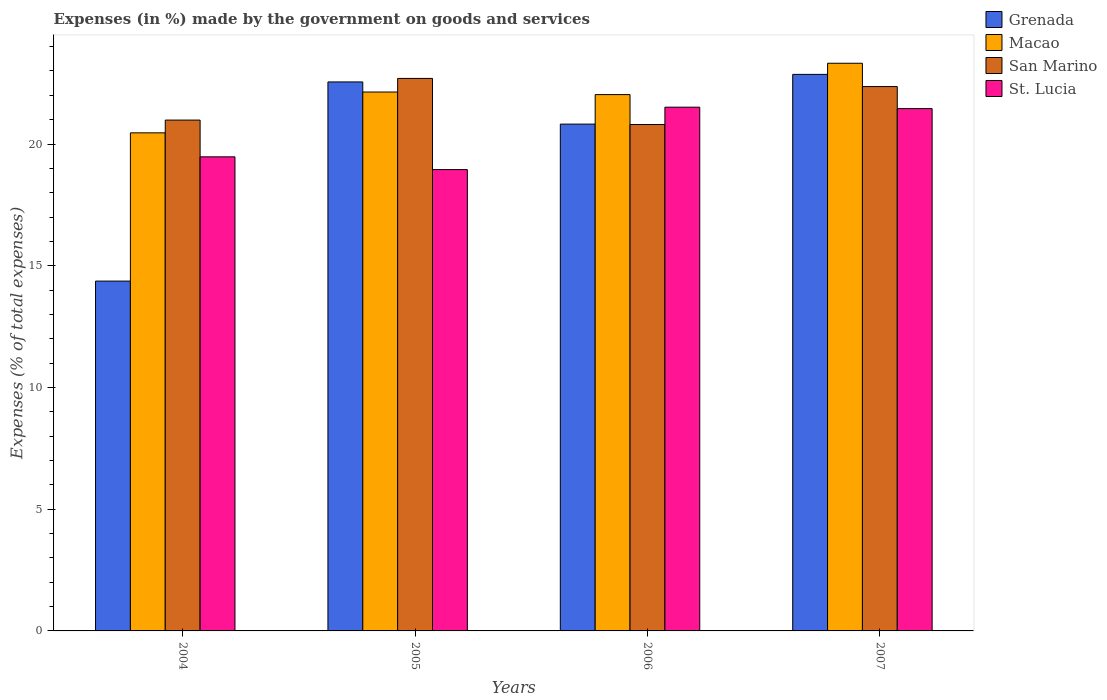How many different coloured bars are there?
Offer a very short reply. 4. Are the number of bars on each tick of the X-axis equal?
Give a very brief answer. Yes. How many bars are there on the 2nd tick from the left?
Provide a short and direct response. 4. What is the label of the 2nd group of bars from the left?
Make the answer very short. 2005. In how many cases, is the number of bars for a given year not equal to the number of legend labels?
Provide a succinct answer. 0. What is the percentage of expenses made by the government on goods and services in Grenada in 2004?
Your answer should be very brief. 14.37. Across all years, what is the maximum percentage of expenses made by the government on goods and services in Grenada?
Keep it short and to the point. 22.86. Across all years, what is the minimum percentage of expenses made by the government on goods and services in Grenada?
Provide a succinct answer. 14.37. In which year was the percentage of expenses made by the government on goods and services in Grenada maximum?
Provide a short and direct response. 2007. In which year was the percentage of expenses made by the government on goods and services in Macao minimum?
Ensure brevity in your answer.  2004. What is the total percentage of expenses made by the government on goods and services in St. Lucia in the graph?
Offer a terse response. 81.39. What is the difference between the percentage of expenses made by the government on goods and services in St. Lucia in 2005 and that in 2006?
Provide a succinct answer. -2.56. What is the difference between the percentage of expenses made by the government on goods and services in San Marino in 2005 and the percentage of expenses made by the government on goods and services in Grenada in 2006?
Your answer should be compact. 1.88. What is the average percentage of expenses made by the government on goods and services in St. Lucia per year?
Offer a very short reply. 20.35. In the year 2004, what is the difference between the percentage of expenses made by the government on goods and services in Grenada and percentage of expenses made by the government on goods and services in St. Lucia?
Offer a very short reply. -5.1. In how many years, is the percentage of expenses made by the government on goods and services in St. Lucia greater than 21 %?
Your answer should be compact. 2. What is the ratio of the percentage of expenses made by the government on goods and services in San Marino in 2006 to that in 2007?
Offer a very short reply. 0.93. Is the percentage of expenses made by the government on goods and services in St. Lucia in 2004 less than that in 2005?
Keep it short and to the point. No. What is the difference between the highest and the second highest percentage of expenses made by the government on goods and services in Grenada?
Your response must be concise. 0.31. What is the difference between the highest and the lowest percentage of expenses made by the government on goods and services in St. Lucia?
Offer a very short reply. 2.56. In how many years, is the percentage of expenses made by the government on goods and services in Grenada greater than the average percentage of expenses made by the government on goods and services in Grenada taken over all years?
Give a very brief answer. 3. Is the sum of the percentage of expenses made by the government on goods and services in San Marino in 2004 and 2007 greater than the maximum percentage of expenses made by the government on goods and services in Macao across all years?
Give a very brief answer. Yes. Is it the case that in every year, the sum of the percentage of expenses made by the government on goods and services in Macao and percentage of expenses made by the government on goods and services in Grenada is greater than the sum of percentage of expenses made by the government on goods and services in San Marino and percentage of expenses made by the government on goods and services in St. Lucia?
Make the answer very short. No. What does the 1st bar from the left in 2004 represents?
Your response must be concise. Grenada. What does the 1st bar from the right in 2006 represents?
Offer a terse response. St. Lucia. Is it the case that in every year, the sum of the percentage of expenses made by the government on goods and services in Grenada and percentage of expenses made by the government on goods and services in Macao is greater than the percentage of expenses made by the government on goods and services in St. Lucia?
Ensure brevity in your answer.  Yes. How many bars are there?
Provide a succinct answer. 16. Are all the bars in the graph horizontal?
Provide a succinct answer. No. How many years are there in the graph?
Keep it short and to the point. 4. Are the values on the major ticks of Y-axis written in scientific E-notation?
Give a very brief answer. No. Does the graph contain any zero values?
Give a very brief answer. No. How many legend labels are there?
Keep it short and to the point. 4. How are the legend labels stacked?
Keep it short and to the point. Vertical. What is the title of the graph?
Keep it short and to the point. Expenses (in %) made by the government on goods and services. What is the label or title of the Y-axis?
Provide a succinct answer. Expenses (% of total expenses). What is the Expenses (% of total expenses) in Grenada in 2004?
Make the answer very short. 14.37. What is the Expenses (% of total expenses) in Macao in 2004?
Your answer should be very brief. 20.46. What is the Expenses (% of total expenses) of San Marino in 2004?
Offer a terse response. 20.98. What is the Expenses (% of total expenses) of St. Lucia in 2004?
Offer a terse response. 19.47. What is the Expenses (% of total expenses) in Grenada in 2005?
Ensure brevity in your answer.  22.55. What is the Expenses (% of total expenses) of Macao in 2005?
Make the answer very short. 22.14. What is the Expenses (% of total expenses) in San Marino in 2005?
Your response must be concise. 22.7. What is the Expenses (% of total expenses) in St. Lucia in 2005?
Keep it short and to the point. 18.95. What is the Expenses (% of total expenses) in Grenada in 2006?
Make the answer very short. 20.82. What is the Expenses (% of total expenses) of Macao in 2006?
Offer a very short reply. 22.03. What is the Expenses (% of total expenses) in San Marino in 2006?
Your response must be concise. 20.8. What is the Expenses (% of total expenses) of St. Lucia in 2006?
Ensure brevity in your answer.  21.51. What is the Expenses (% of total expenses) of Grenada in 2007?
Provide a short and direct response. 22.86. What is the Expenses (% of total expenses) of Macao in 2007?
Your answer should be compact. 23.32. What is the Expenses (% of total expenses) in San Marino in 2007?
Offer a very short reply. 22.36. What is the Expenses (% of total expenses) of St. Lucia in 2007?
Give a very brief answer. 21.46. Across all years, what is the maximum Expenses (% of total expenses) in Grenada?
Offer a very short reply. 22.86. Across all years, what is the maximum Expenses (% of total expenses) of Macao?
Ensure brevity in your answer.  23.32. Across all years, what is the maximum Expenses (% of total expenses) in San Marino?
Offer a terse response. 22.7. Across all years, what is the maximum Expenses (% of total expenses) in St. Lucia?
Provide a succinct answer. 21.51. Across all years, what is the minimum Expenses (% of total expenses) in Grenada?
Give a very brief answer. 14.37. Across all years, what is the minimum Expenses (% of total expenses) of Macao?
Provide a short and direct response. 20.46. Across all years, what is the minimum Expenses (% of total expenses) in San Marino?
Give a very brief answer. 20.8. Across all years, what is the minimum Expenses (% of total expenses) of St. Lucia?
Give a very brief answer. 18.95. What is the total Expenses (% of total expenses) of Grenada in the graph?
Ensure brevity in your answer.  80.6. What is the total Expenses (% of total expenses) in Macao in the graph?
Make the answer very short. 87.94. What is the total Expenses (% of total expenses) in San Marino in the graph?
Your answer should be very brief. 86.84. What is the total Expenses (% of total expenses) in St. Lucia in the graph?
Provide a succinct answer. 81.39. What is the difference between the Expenses (% of total expenses) of Grenada in 2004 and that in 2005?
Offer a very short reply. -8.18. What is the difference between the Expenses (% of total expenses) in Macao in 2004 and that in 2005?
Make the answer very short. -1.68. What is the difference between the Expenses (% of total expenses) of San Marino in 2004 and that in 2005?
Offer a very short reply. -1.71. What is the difference between the Expenses (% of total expenses) in St. Lucia in 2004 and that in 2005?
Give a very brief answer. 0.52. What is the difference between the Expenses (% of total expenses) of Grenada in 2004 and that in 2006?
Provide a short and direct response. -6.45. What is the difference between the Expenses (% of total expenses) in Macao in 2004 and that in 2006?
Keep it short and to the point. -1.57. What is the difference between the Expenses (% of total expenses) of San Marino in 2004 and that in 2006?
Your answer should be compact. 0.18. What is the difference between the Expenses (% of total expenses) in St. Lucia in 2004 and that in 2006?
Ensure brevity in your answer.  -2.04. What is the difference between the Expenses (% of total expenses) of Grenada in 2004 and that in 2007?
Keep it short and to the point. -8.49. What is the difference between the Expenses (% of total expenses) in Macao in 2004 and that in 2007?
Give a very brief answer. -2.86. What is the difference between the Expenses (% of total expenses) of San Marino in 2004 and that in 2007?
Give a very brief answer. -1.38. What is the difference between the Expenses (% of total expenses) of St. Lucia in 2004 and that in 2007?
Your answer should be very brief. -1.98. What is the difference between the Expenses (% of total expenses) of Grenada in 2005 and that in 2006?
Make the answer very short. 1.73. What is the difference between the Expenses (% of total expenses) of Macao in 2005 and that in 2006?
Provide a short and direct response. 0.11. What is the difference between the Expenses (% of total expenses) in San Marino in 2005 and that in 2006?
Your answer should be compact. 1.89. What is the difference between the Expenses (% of total expenses) of St. Lucia in 2005 and that in 2006?
Keep it short and to the point. -2.56. What is the difference between the Expenses (% of total expenses) of Grenada in 2005 and that in 2007?
Make the answer very short. -0.31. What is the difference between the Expenses (% of total expenses) in Macao in 2005 and that in 2007?
Provide a succinct answer. -1.18. What is the difference between the Expenses (% of total expenses) of San Marino in 2005 and that in 2007?
Provide a succinct answer. 0.34. What is the difference between the Expenses (% of total expenses) in St. Lucia in 2005 and that in 2007?
Your response must be concise. -2.5. What is the difference between the Expenses (% of total expenses) in Grenada in 2006 and that in 2007?
Offer a very short reply. -2.04. What is the difference between the Expenses (% of total expenses) in Macao in 2006 and that in 2007?
Give a very brief answer. -1.29. What is the difference between the Expenses (% of total expenses) of San Marino in 2006 and that in 2007?
Provide a succinct answer. -1.56. What is the difference between the Expenses (% of total expenses) in St. Lucia in 2006 and that in 2007?
Ensure brevity in your answer.  0.06. What is the difference between the Expenses (% of total expenses) in Grenada in 2004 and the Expenses (% of total expenses) in Macao in 2005?
Your answer should be very brief. -7.77. What is the difference between the Expenses (% of total expenses) in Grenada in 2004 and the Expenses (% of total expenses) in San Marino in 2005?
Offer a very short reply. -8.33. What is the difference between the Expenses (% of total expenses) of Grenada in 2004 and the Expenses (% of total expenses) of St. Lucia in 2005?
Your answer should be very brief. -4.58. What is the difference between the Expenses (% of total expenses) in Macao in 2004 and the Expenses (% of total expenses) in San Marino in 2005?
Ensure brevity in your answer.  -2.24. What is the difference between the Expenses (% of total expenses) in Macao in 2004 and the Expenses (% of total expenses) in St. Lucia in 2005?
Offer a terse response. 1.51. What is the difference between the Expenses (% of total expenses) of San Marino in 2004 and the Expenses (% of total expenses) of St. Lucia in 2005?
Your answer should be compact. 2.03. What is the difference between the Expenses (% of total expenses) in Grenada in 2004 and the Expenses (% of total expenses) in Macao in 2006?
Provide a succinct answer. -7.66. What is the difference between the Expenses (% of total expenses) of Grenada in 2004 and the Expenses (% of total expenses) of San Marino in 2006?
Make the answer very short. -6.43. What is the difference between the Expenses (% of total expenses) of Grenada in 2004 and the Expenses (% of total expenses) of St. Lucia in 2006?
Your answer should be compact. -7.14. What is the difference between the Expenses (% of total expenses) of Macao in 2004 and the Expenses (% of total expenses) of San Marino in 2006?
Keep it short and to the point. -0.34. What is the difference between the Expenses (% of total expenses) in Macao in 2004 and the Expenses (% of total expenses) in St. Lucia in 2006?
Provide a succinct answer. -1.05. What is the difference between the Expenses (% of total expenses) of San Marino in 2004 and the Expenses (% of total expenses) of St. Lucia in 2006?
Offer a terse response. -0.53. What is the difference between the Expenses (% of total expenses) of Grenada in 2004 and the Expenses (% of total expenses) of Macao in 2007?
Make the answer very short. -8.95. What is the difference between the Expenses (% of total expenses) in Grenada in 2004 and the Expenses (% of total expenses) in San Marino in 2007?
Ensure brevity in your answer.  -7.99. What is the difference between the Expenses (% of total expenses) of Grenada in 2004 and the Expenses (% of total expenses) of St. Lucia in 2007?
Offer a very short reply. -7.08. What is the difference between the Expenses (% of total expenses) in Macao in 2004 and the Expenses (% of total expenses) in San Marino in 2007?
Ensure brevity in your answer.  -1.9. What is the difference between the Expenses (% of total expenses) of Macao in 2004 and the Expenses (% of total expenses) of St. Lucia in 2007?
Keep it short and to the point. -1. What is the difference between the Expenses (% of total expenses) of San Marino in 2004 and the Expenses (% of total expenses) of St. Lucia in 2007?
Offer a very short reply. -0.47. What is the difference between the Expenses (% of total expenses) in Grenada in 2005 and the Expenses (% of total expenses) in Macao in 2006?
Your response must be concise. 0.52. What is the difference between the Expenses (% of total expenses) of Grenada in 2005 and the Expenses (% of total expenses) of San Marino in 2006?
Your response must be concise. 1.75. What is the difference between the Expenses (% of total expenses) in Grenada in 2005 and the Expenses (% of total expenses) in St. Lucia in 2006?
Offer a very short reply. 1.04. What is the difference between the Expenses (% of total expenses) of Macao in 2005 and the Expenses (% of total expenses) of San Marino in 2006?
Your answer should be very brief. 1.34. What is the difference between the Expenses (% of total expenses) of Macao in 2005 and the Expenses (% of total expenses) of St. Lucia in 2006?
Provide a short and direct response. 0.62. What is the difference between the Expenses (% of total expenses) in San Marino in 2005 and the Expenses (% of total expenses) in St. Lucia in 2006?
Your answer should be compact. 1.18. What is the difference between the Expenses (% of total expenses) in Grenada in 2005 and the Expenses (% of total expenses) in Macao in 2007?
Provide a short and direct response. -0.77. What is the difference between the Expenses (% of total expenses) of Grenada in 2005 and the Expenses (% of total expenses) of San Marino in 2007?
Ensure brevity in your answer.  0.19. What is the difference between the Expenses (% of total expenses) of Grenada in 2005 and the Expenses (% of total expenses) of St. Lucia in 2007?
Offer a terse response. 1.1. What is the difference between the Expenses (% of total expenses) in Macao in 2005 and the Expenses (% of total expenses) in San Marino in 2007?
Your response must be concise. -0.22. What is the difference between the Expenses (% of total expenses) of Macao in 2005 and the Expenses (% of total expenses) of St. Lucia in 2007?
Keep it short and to the point. 0.68. What is the difference between the Expenses (% of total expenses) of San Marino in 2005 and the Expenses (% of total expenses) of St. Lucia in 2007?
Offer a terse response. 1.24. What is the difference between the Expenses (% of total expenses) of Grenada in 2006 and the Expenses (% of total expenses) of Macao in 2007?
Offer a very short reply. -2.5. What is the difference between the Expenses (% of total expenses) in Grenada in 2006 and the Expenses (% of total expenses) in San Marino in 2007?
Provide a succinct answer. -1.54. What is the difference between the Expenses (% of total expenses) in Grenada in 2006 and the Expenses (% of total expenses) in St. Lucia in 2007?
Your answer should be very brief. -0.64. What is the difference between the Expenses (% of total expenses) of Macao in 2006 and the Expenses (% of total expenses) of San Marino in 2007?
Offer a terse response. -0.33. What is the difference between the Expenses (% of total expenses) of Macao in 2006 and the Expenses (% of total expenses) of St. Lucia in 2007?
Provide a short and direct response. 0.58. What is the difference between the Expenses (% of total expenses) in San Marino in 2006 and the Expenses (% of total expenses) in St. Lucia in 2007?
Provide a succinct answer. -0.65. What is the average Expenses (% of total expenses) of Grenada per year?
Provide a succinct answer. 20.15. What is the average Expenses (% of total expenses) in Macao per year?
Offer a very short reply. 21.99. What is the average Expenses (% of total expenses) in San Marino per year?
Provide a succinct answer. 21.71. What is the average Expenses (% of total expenses) in St. Lucia per year?
Your response must be concise. 20.35. In the year 2004, what is the difference between the Expenses (% of total expenses) in Grenada and Expenses (% of total expenses) in Macao?
Provide a succinct answer. -6.09. In the year 2004, what is the difference between the Expenses (% of total expenses) of Grenada and Expenses (% of total expenses) of San Marino?
Offer a terse response. -6.61. In the year 2004, what is the difference between the Expenses (% of total expenses) of Grenada and Expenses (% of total expenses) of St. Lucia?
Provide a short and direct response. -5.1. In the year 2004, what is the difference between the Expenses (% of total expenses) of Macao and Expenses (% of total expenses) of San Marino?
Keep it short and to the point. -0.52. In the year 2004, what is the difference between the Expenses (% of total expenses) in Macao and Expenses (% of total expenses) in St. Lucia?
Your answer should be compact. 0.99. In the year 2004, what is the difference between the Expenses (% of total expenses) of San Marino and Expenses (% of total expenses) of St. Lucia?
Provide a succinct answer. 1.51. In the year 2005, what is the difference between the Expenses (% of total expenses) in Grenada and Expenses (% of total expenses) in Macao?
Make the answer very short. 0.41. In the year 2005, what is the difference between the Expenses (% of total expenses) in Grenada and Expenses (% of total expenses) in San Marino?
Provide a short and direct response. -0.14. In the year 2005, what is the difference between the Expenses (% of total expenses) of Grenada and Expenses (% of total expenses) of St. Lucia?
Offer a terse response. 3.6. In the year 2005, what is the difference between the Expenses (% of total expenses) in Macao and Expenses (% of total expenses) in San Marino?
Provide a short and direct response. -0.56. In the year 2005, what is the difference between the Expenses (% of total expenses) in Macao and Expenses (% of total expenses) in St. Lucia?
Your answer should be compact. 3.19. In the year 2005, what is the difference between the Expenses (% of total expenses) in San Marino and Expenses (% of total expenses) in St. Lucia?
Your response must be concise. 3.75. In the year 2006, what is the difference between the Expenses (% of total expenses) of Grenada and Expenses (% of total expenses) of Macao?
Keep it short and to the point. -1.21. In the year 2006, what is the difference between the Expenses (% of total expenses) in Grenada and Expenses (% of total expenses) in San Marino?
Offer a very short reply. 0.02. In the year 2006, what is the difference between the Expenses (% of total expenses) of Grenada and Expenses (% of total expenses) of St. Lucia?
Provide a succinct answer. -0.7. In the year 2006, what is the difference between the Expenses (% of total expenses) of Macao and Expenses (% of total expenses) of San Marino?
Offer a very short reply. 1.23. In the year 2006, what is the difference between the Expenses (% of total expenses) of Macao and Expenses (% of total expenses) of St. Lucia?
Your answer should be compact. 0.52. In the year 2006, what is the difference between the Expenses (% of total expenses) in San Marino and Expenses (% of total expenses) in St. Lucia?
Your answer should be compact. -0.71. In the year 2007, what is the difference between the Expenses (% of total expenses) of Grenada and Expenses (% of total expenses) of Macao?
Provide a short and direct response. -0.46. In the year 2007, what is the difference between the Expenses (% of total expenses) in Grenada and Expenses (% of total expenses) in San Marino?
Keep it short and to the point. 0.5. In the year 2007, what is the difference between the Expenses (% of total expenses) of Grenada and Expenses (% of total expenses) of St. Lucia?
Offer a terse response. 1.41. In the year 2007, what is the difference between the Expenses (% of total expenses) of Macao and Expenses (% of total expenses) of San Marino?
Your answer should be very brief. 0.96. In the year 2007, what is the difference between the Expenses (% of total expenses) in Macao and Expenses (% of total expenses) in St. Lucia?
Provide a succinct answer. 1.86. In the year 2007, what is the difference between the Expenses (% of total expenses) in San Marino and Expenses (% of total expenses) in St. Lucia?
Ensure brevity in your answer.  0.91. What is the ratio of the Expenses (% of total expenses) of Grenada in 2004 to that in 2005?
Keep it short and to the point. 0.64. What is the ratio of the Expenses (% of total expenses) of Macao in 2004 to that in 2005?
Offer a very short reply. 0.92. What is the ratio of the Expenses (% of total expenses) of San Marino in 2004 to that in 2005?
Make the answer very short. 0.92. What is the ratio of the Expenses (% of total expenses) in St. Lucia in 2004 to that in 2005?
Offer a terse response. 1.03. What is the ratio of the Expenses (% of total expenses) of Grenada in 2004 to that in 2006?
Your answer should be compact. 0.69. What is the ratio of the Expenses (% of total expenses) of Macao in 2004 to that in 2006?
Ensure brevity in your answer.  0.93. What is the ratio of the Expenses (% of total expenses) in San Marino in 2004 to that in 2006?
Make the answer very short. 1.01. What is the ratio of the Expenses (% of total expenses) of St. Lucia in 2004 to that in 2006?
Ensure brevity in your answer.  0.91. What is the ratio of the Expenses (% of total expenses) of Grenada in 2004 to that in 2007?
Ensure brevity in your answer.  0.63. What is the ratio of the Expenses (% of total expenses) in Macao in 2004 to that in 2007?
Your response must be concise. 0.88. What is the ratio of the Expenses (% of total expenses) in San Marino in 2004 to that in 2007?
Provide a succinct answer. 0.94. What is the ratio of the Expenses (% of total expenses) of St. Lucia in 2004 to that in 2007?
Your answer should be very brief. 0.91. What is the ratio of the Expenses (% of total expenses) in Grenada in 2005 to that in 2006?
Make the answer very short. 1.08. What is the ratio of the Expenses (% of total expenses) in Macao in 2005 to that in 2006?
Ensure brevity in your answer.  1. What is the ratio of the Expenses (% of total expenses) of San Marino in 2005 to that in 2006?
Give a very brief answer. 1.09. What is the ratio of the Expenses (% of total expenses) in St. Lucia in 2005 to that in 2006?
Offer a very short reply. 0.88. What is the ratio of the Expenses (% of total expenses) in Grenada in 2005 to that in 2007?
Provide a succinct answer. 0.99. What is the ratio of the Expenses (% of total expenses) of Macao in 2005 to that in 2007?
Offer a very short reply. 0.95. What is the ratio of the Expenses (% of total expenses) in San Marino in 2005 to that in 2007?
Your answer should be compact. 1.01. What is the ratio of the Expenses (% of total expenses) in St. Lucia in 2005 to that in 2007?
Keep it short and to the point. 0.88. What is the ratio of the Expenses (% of total expenses) of Grenada in 2006 to that in 2007?
Make the answer very short. 0.91. What is the ratio of the Expenses (% of total expenses) in Macao in 2006 to that in 2007?
Ensure brevity in your answer.  0.94. What is the ratio of the Expenses (% of total expenses) in San Marino in 2006 to that in 2007?
Provide a succinct answer. 0.93. What is the ratio of the Expenses (% of total expenses) in St. Lucia in 2006 to that in 2007?
Your answer should be very brief. 1. What is the difference between the highest and the second highest Expenses (% of total expenses) of Grenada?
Offer a very short reply. 0.31. What is the difference between the highest and the second highest Expenses (% of total expenses) of Macao?
Provide a short and direct response. 1.18. What is the difference between the highest and the second highest Expenses (% of total expenses) of San Marino?
Give a very brief answer. 0.34. What is the difference between the highest and the second highest Expenses (% of total expenses) of St. Lucia?
Offer a very short reply. 0.06. What is the difference between the highest and the lowest Expenses (% of total expenses) in Grenada?
Keep it short and to the point. 8.49. What is the difference between the highest and the lowest Expenses (% of total expenses) in Macao?
Give a very brief answer. 2.86. What is the difference between the highest and the lowest Expenses (% of total expenses) of San Marino?
Your answer should be compact. 1.89. What is the difference between the highest and the lowest Expenses (% of total expenses) of St. Lucia?
Provide a succinct answer. 2.56. 